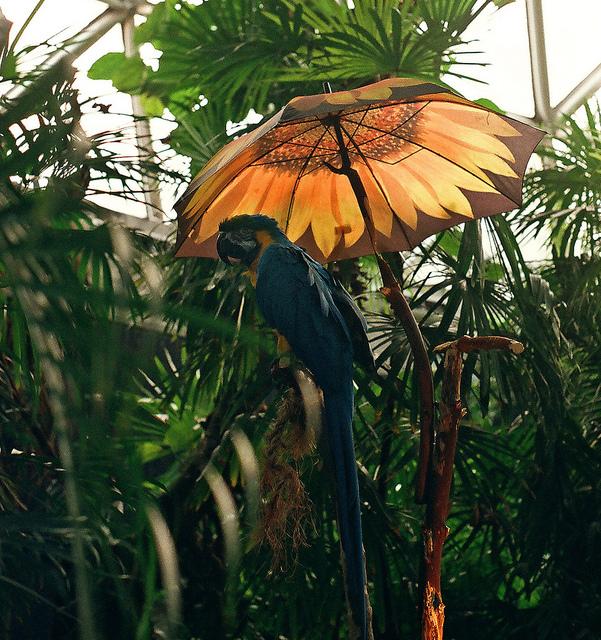Is the scene indoors?
Give a very brief answer. Yes. What type of bird is this?
Quick response, please. Parrot. Is there an umbrella?
Write a very short answer. Yes. 